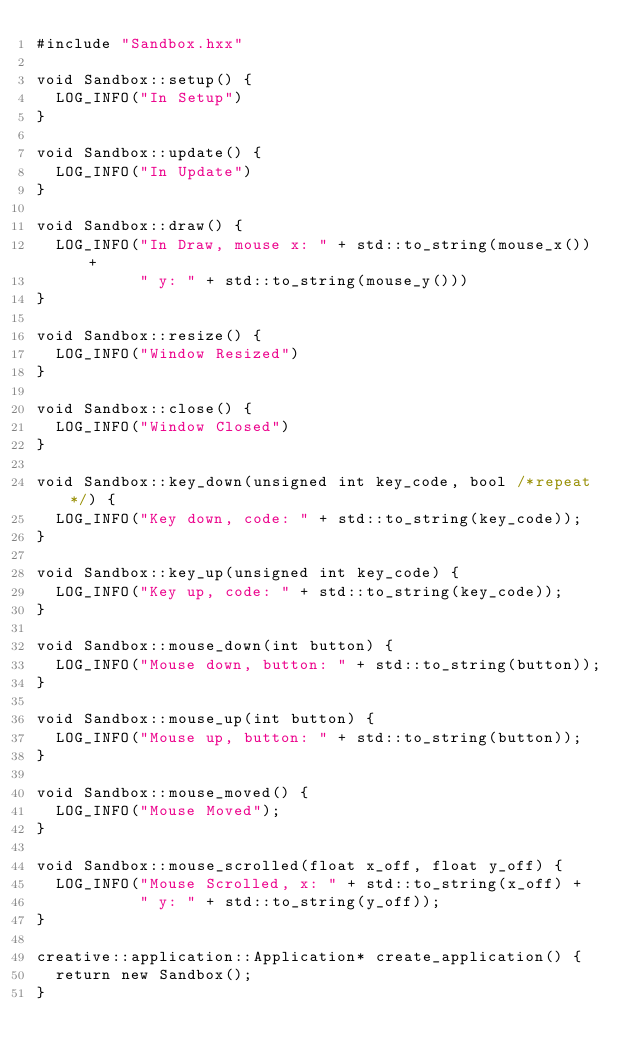Convert code to text. <code><loc_0><loc_0><loc_500><loc_500><_C++_>#include "Sandbox.hxx"

void Sandbox::setup() {
  LOG_INFO("In Setup")
}

void Sandbox::update() {
  LOG_INFO("In Update")
}

void Sandbox::draw() {
  LOG_INFO("In Draw, mouse x: " + std::to_string(mouse_x()) +
           " y: " + std::to_string(mouse_y()))
}

void Sandbox::resize() {
  LOG_INFO("Window Resized")
}

void Sandbox::close() {
  LOG_INFO("Window Closed")
}

void Sandbox::key_down(unsigned int key_code, bool /*repeat*/) {
  LOG_INFO("Key down, code: " + std::to_string(key_code));
}

void Sandbox::key_up(unsigned int key_code) {
  LOG_INFO("Key up, code: " + std::to_string(key_code));
}

void Sandbox::mouse_down(int button) {
  LOG_INFO("Mouse down, button: " + std::to_string(button));
}

void Sandbox::mouse_up(int button) {
  LOG_INFO("Mouse up, button: " + std::to_string(button));
}

void Sandbox::mouse_moved() {
  LOG_INFO("Mouse Moved");
}

void Sandbox::mouse_scrolled(float x_off, float y_off) {
  LOG_INFO("Mouse Scrolled, x: " + std::to_string(x_off) +
           " y: " + std::to_string(y_off));
}

creative::application::Application* create_application() {
  return new Sandbox();
}
</code> 